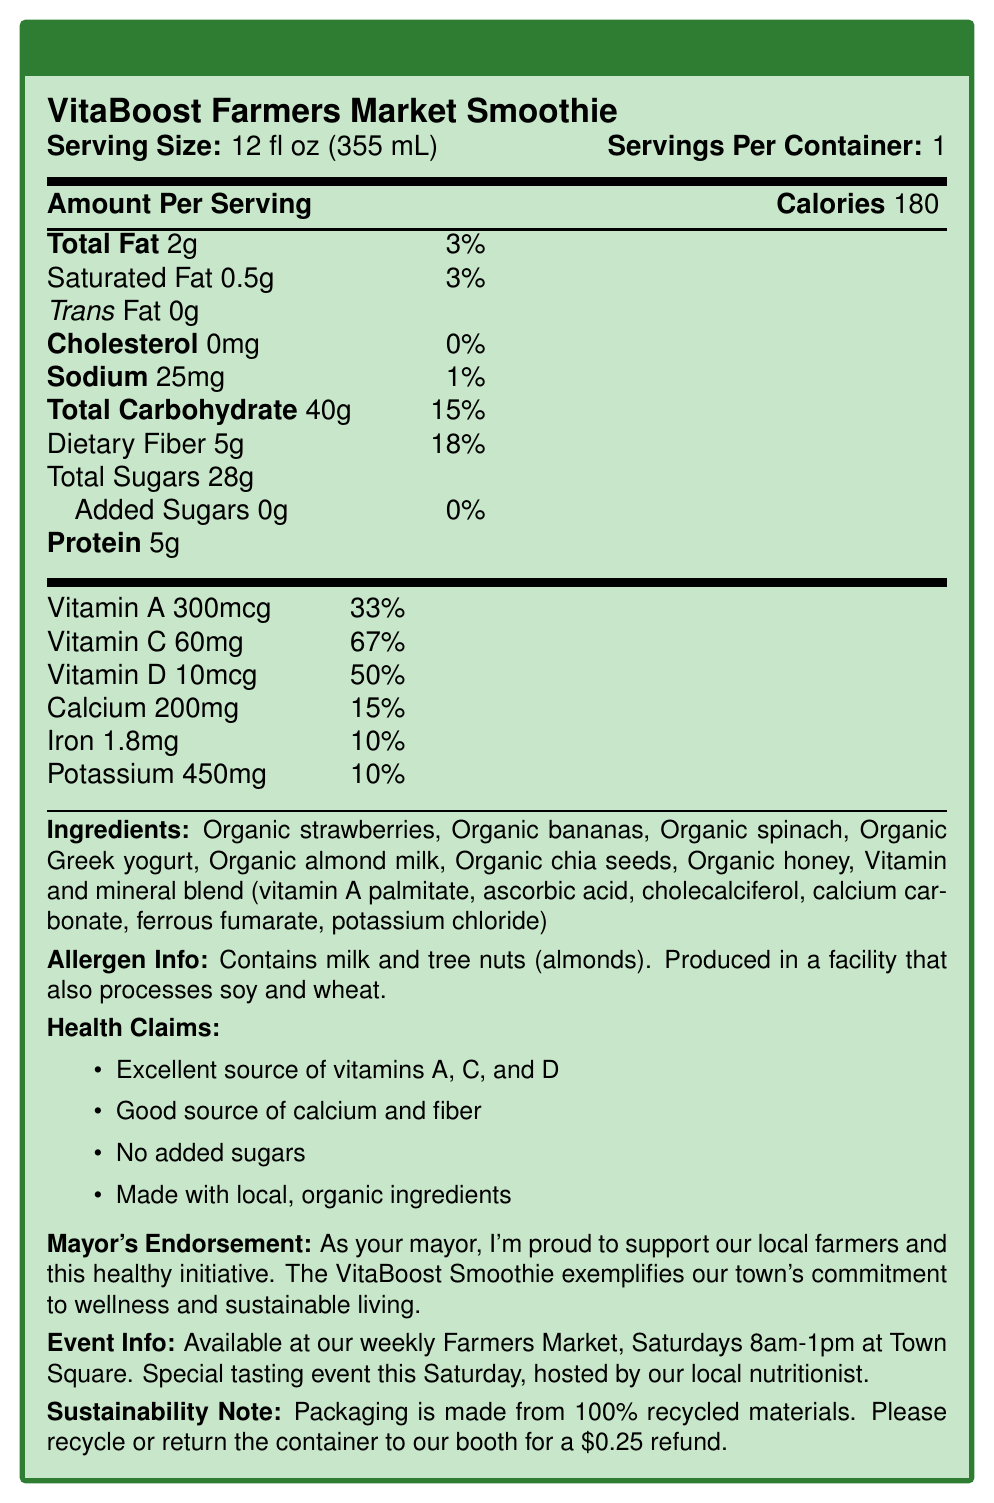what is the serving size? The document explicitly states the serving size as "12 fl oz (355 mL)".
Answer: 12 fl oz (355 mL) how many calories are in one serving? The document lists the calorie content under "Amount Per Serving" as 180 calories.
Answer: 180 calories what is the total fat percentage of the daily value? The document shows "Total Fat" is 2g, and the daily value percentage is listed as 3%.
Answer: 3% what are the main ingredients? The document provides a detailed list of the ingredients under the "Ingredients" section.
Answer: The main ingredients are organic strawberries, organic bananas, organic spinach, organic Greek yogurt, organic almond milk, organic chia seeds, organic honey, and vitamin and mineral blend. how much protein does one serving contain? The amount of protein per serving is listed as 5g in the document.
Answer: 5g which vitamins are present in significant amounts? A. Vitamin A and Vitamin D B. Vitamin B and Vitamin C C. Vitamin A, Vitamin C, and Vitamin D The document lists vitamins A (33% daily value), C (67% daily value), and D (50% daily value) as the dominant vitamins, making option C correct.
Answer: C how much sodium is in one serving? A. 20mg B. 25mg C. 30mg The document specifies that the sodium content in one serving is 25mg.
Answer: B is there any cholesterol in this product? The document indicates that the cholesterol content is "0mg", corresponding to 0%.
Answer: No does this product contain soy? The document mentions that the product is produced in a facility that also processes soy, but it does not list soy as an ingredient.
Answer: No what is the mayor's endorsement? This specific text is listed under the "Mayor's Endorsement" section in the document.
Answer: As your mayor, I'm proud to support our local farmers and this healthy initiative. The VitaBoost Smoothie exemplifies our town's commitment to wellness and sustainable living. can the packaging be recycled? The document specifies in the "Sustainability Note" that the packaging is made from 100% recycled materials and encourages recycling or returning the container.
Answer: Yes what is the health claims section trying to convey? The document lists these specific points under the "Health Claims" section.
Answer: The health claim highlights the product as an excellent source of vitamins A, C, and D, a good source of calcium and fiber, no added sugars, and that it is made with local, organic ingredients. how much dietary fiber is in one serving? The dietary fiber content is listed as 5g in one serving.
Answer: 5g when is the VitaBoost Smoothie available at the Farmers Market? The document states that the VitaBoost Smoothie is available at the weekly Farmers Market on Saturdays from 8am to 1pm at Town Square.
Answer: Saturdays 8am-1pm at Town Square what percent of the daily value of vitamin C is provided by this product? The document states that the daily value percentage for vitamin C is 67%.
Answer: 67% how much calcium does this product contain? The amount of calcium in one serving is listed as 200mg.
Answer: 200mg where can I taste this smoothie blend? This information is provided in the "Event Info" section of the document.
Answer: At the special tasting event this Saturday hosted by a local nutritionist. what is the total carbohydrate content per serving? The total carbohydrate amount per serving is listed in the document as 40g.
Answer: 40g do the ingredients include any artificial flavors? The ingredients listed are all organic components and a vitamin and mineral blend, with no mention of artificial flavors.
Answer: No will it be possible to determine how many containers are sold weekly? The document does not provide any sales data or statistics that would allow for determining the number of containers sold weekly.
Answer: Not enough information 